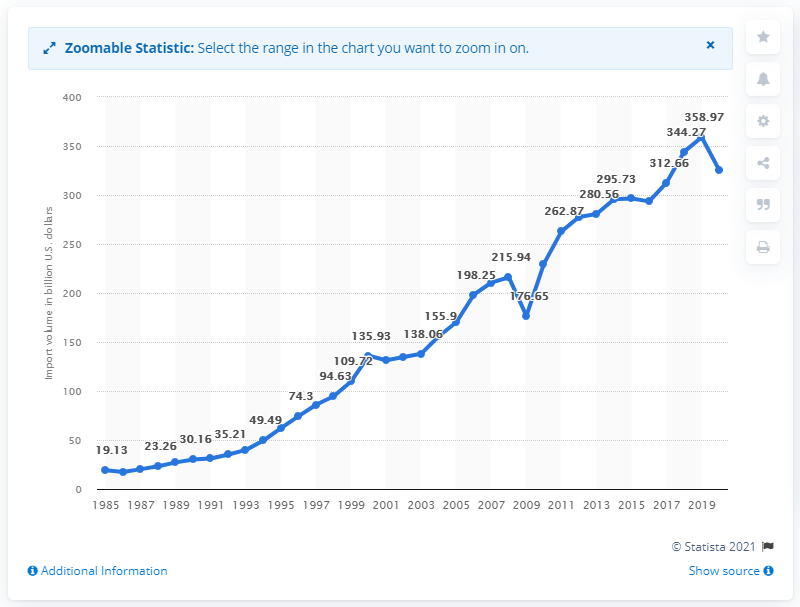List a handful of essential elements in this visual. In 2020, the value of U.S. imports from Mexico was 325.39 billion dollars. 